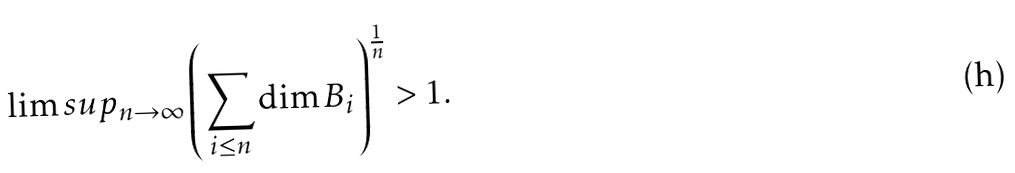<formula> <loc_0><loc_0><loc_500><loc_500>\lim s u p _ { n \to \infty } \left ( \sum _ { i \leq n } \dim B _ { i } \right ) ^ { \frac { 1 } { n } } > 1 .</formula> 